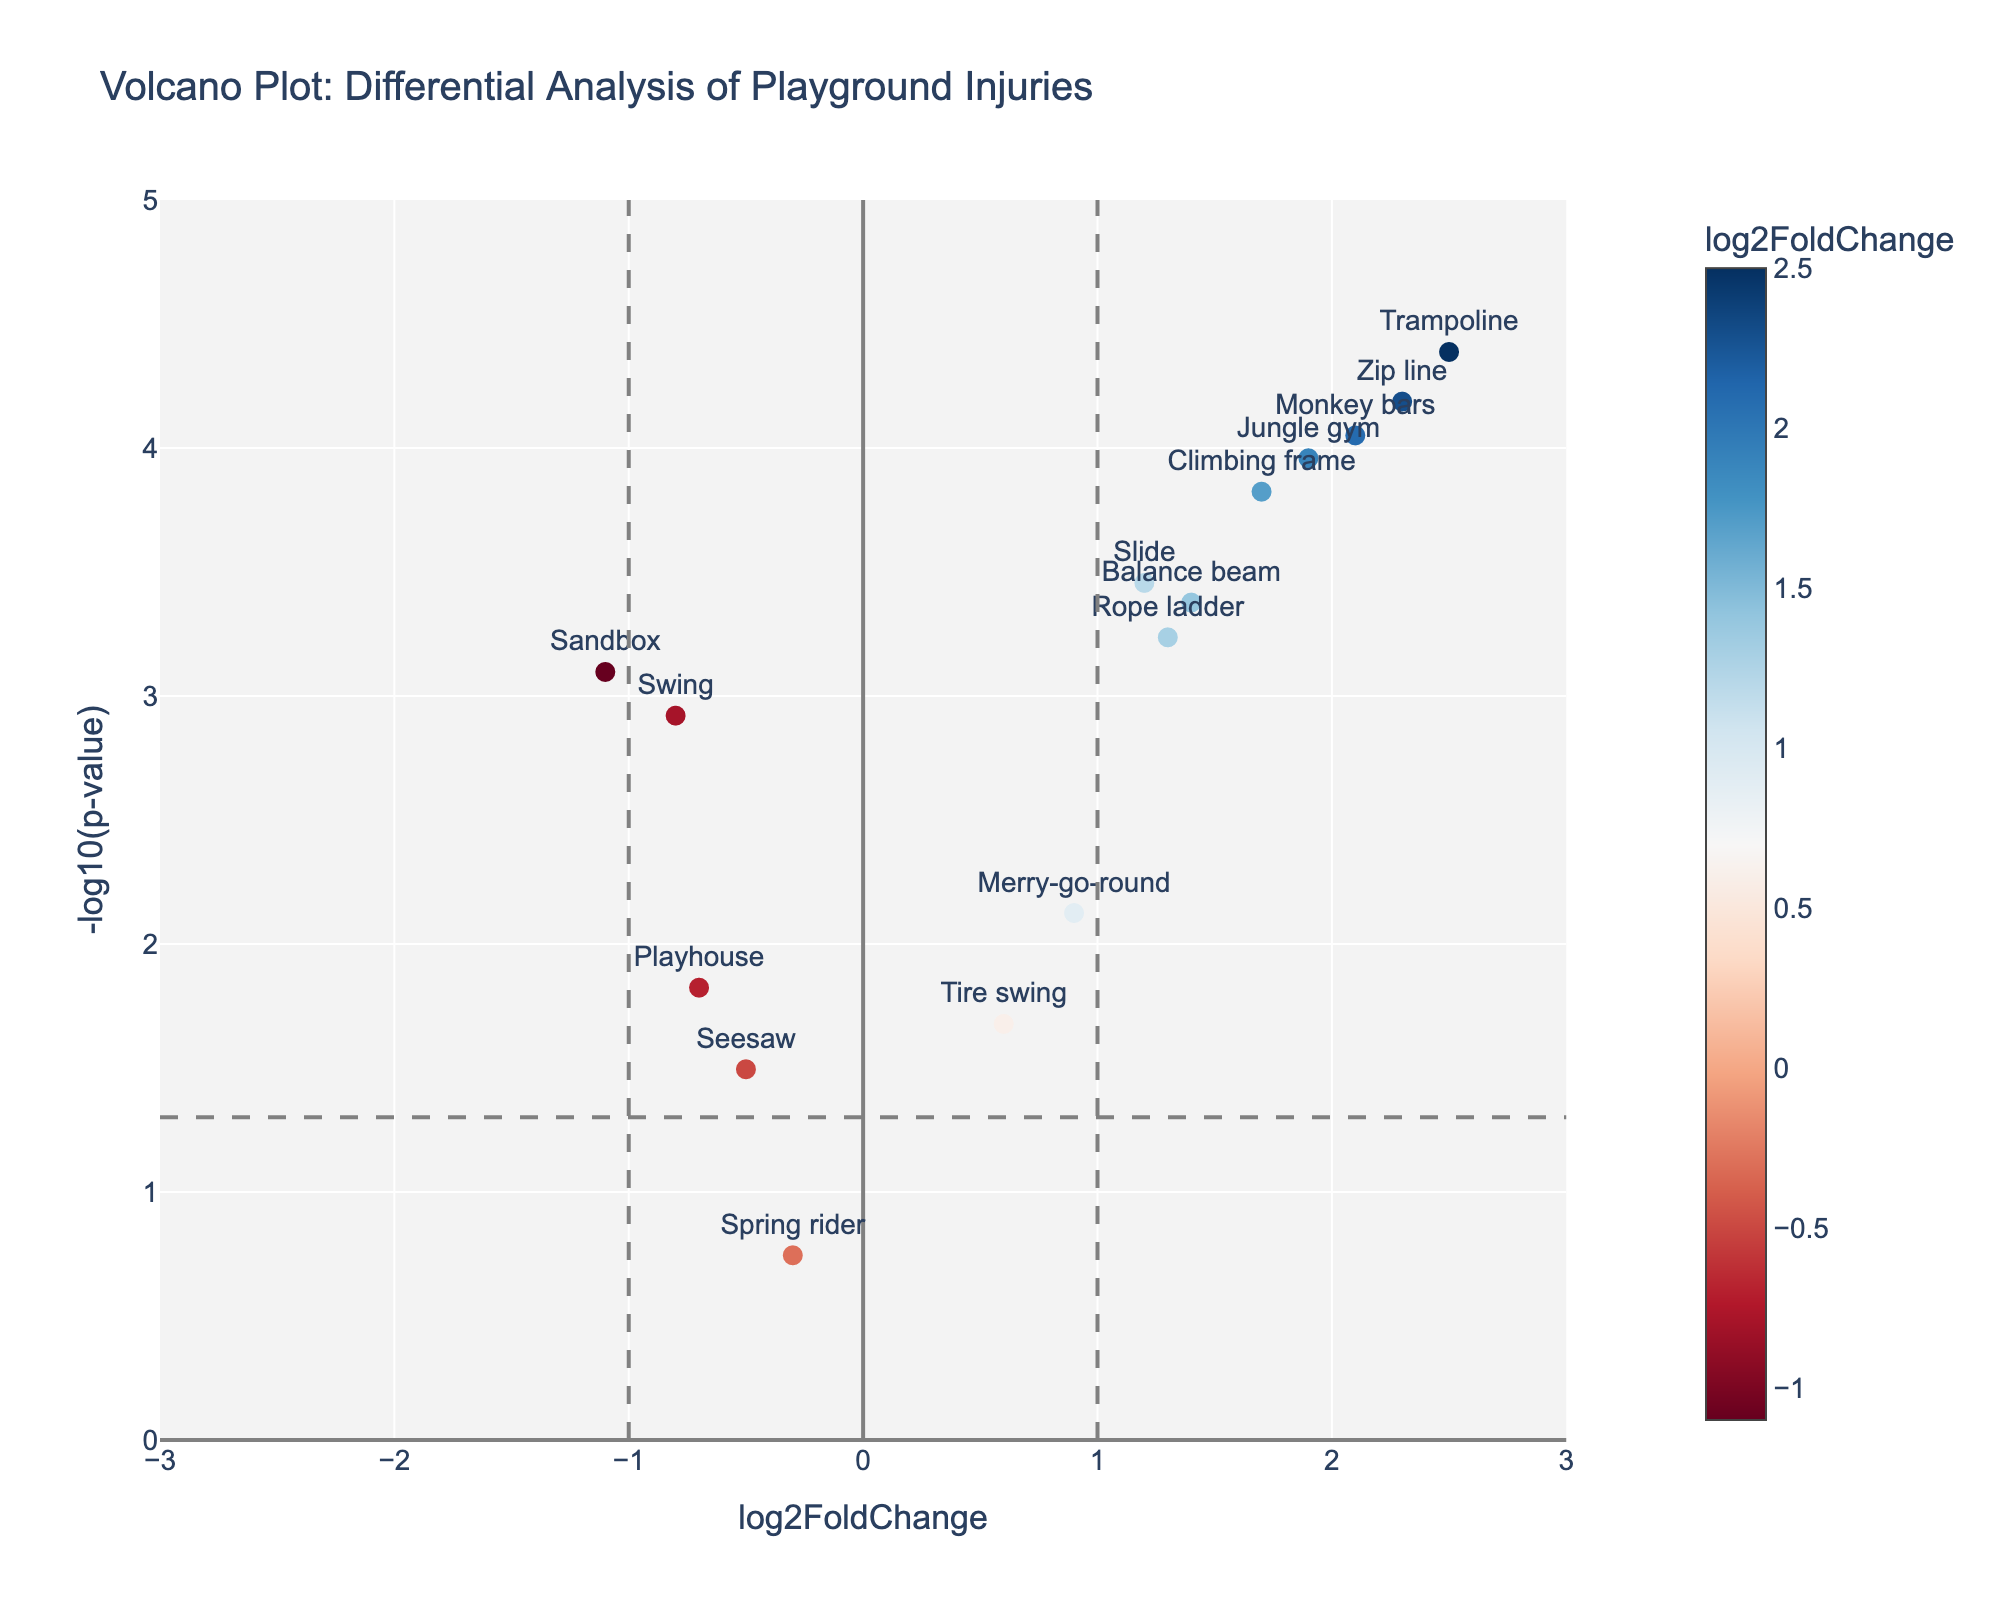What is the title of the figure? At the top of the figure, the title is usually displayed, which helps identify the topic of the visualized data.
Answer: Volcano Plot: Differential Analysis of Playground Injuries How many equipment types have a log2FoldChange greater than 2? By examining the x-axis for points to the right of the value 2, we can count the equipment types.
Answer: 3 Which playground equipment has the lowest p-value? The lowest p-value will correspond to the highest point on the y-axis since the figure uses -log10(p-value).
Answer: Trampoline What are the log2FoldChange and p-value of the Monkey bars? Locate the point labeled "Monkey bars" and read the x and y coordinates. Then convert -log10(p-value) back to p-value.
Answer: log2FoldChange: 2.1, p-value: 0.000089 Which equipment shows the most significant negative fold change? The most significant negative fold change will be the point farthest to the left on the x-axis amongst all the points.
Answer: Sandbox How many equipment types have a -log10(p-value) greater than 3? Count the number of points that lie above the y-value of 3 on the y-axis.
Answer: 6 Which equipment type has the closest log2FoldChange to 1 but is not exactly 1? Look for the point near x=1 and compare the log2FoldChange values.
Answer: Balance beam What is the log2FoldChange range of the equipment types displayed in the figure? Determine the difference between the maximum and minimum log2FoldChange values on the x-axis.
Answer: -1.1 to 2.5 Are there more equipment types with a positive or negative log2FoldChange? Compare the number of points on the right side of 0 (positive) with the left side of 0 (negative) on the x-axis.
Answer: Positive log2FoldChange Which equipment types have both a significant p-value (p < 0.05) and a log2FoldChange greater than 1? Identify points with a y-value higher than -log10(0.05) and an x-value greater than 1. Count these points.
Answer: Slide, Climbing frame, Rope ladder, Jungle gym, Zip line, Trampoline 